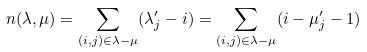Convert formula to latex. <formula><loc_0><loc_0><loc_500><loc_500>n ( \lambda , \mu ) = \sum _ { ( i , j ) \in \lambda - \mu } ( \lambda _ { j } ^ { \prime } - i ) = \sum _ { ( i , j ) \in \lambda - \mu } ( i - \mu _ { j } ^ { \prime } - 1 )</formula> 